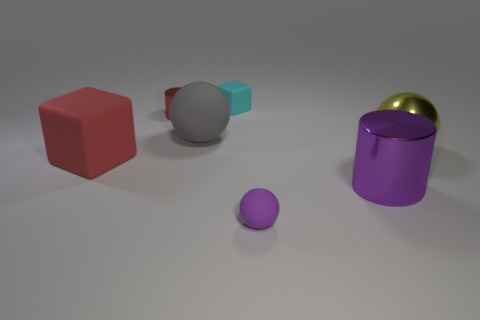How many objects are both right of the small block and to the left of the yellow metallic thing?
Your response must be concise. 2. There is a rubber object behind the shiny thing that is on the left side of the cyan block; what size is it?
Your response must be concise. Small. Is the number of small purple spheres that are in front of the small ball less than the number of tiny rubber blocks to the right of the purple shiny cylinder?
Ensure brevity in your answer.  No. Is the color of the small matte object that is to the right of the small cyan rubber cube the same as the large sphere that is on the left side of the purple rubber object?
Give a very brief answer. No. There is a small object that is both right of the tiny red cylinder and behind the purple cylinder; what is it made of?
Provide a succinct answer. Rubber. Is there a large gray rubber sphere?
Keep it short and to the point. Yes. What shape is the red object that is the same material as the tiny purple sphere?
Offer a very short reply. Cube. There is a large purple thing; does it have the same shape as the rubber thing that is right of the cyan rubber thing?
Provide a short and direct response. No. What material is the purple object left of the purple metallic thing that is on the right side of the gray object?
Your response must be concise. Rubber. How many other things are the same shape as the gray object?
Give a very brief answer. 2. 